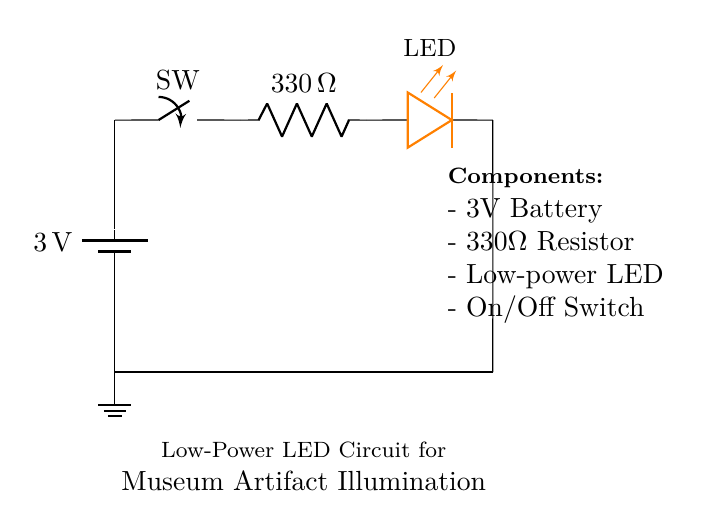What is the voltage of this circuit? The voltage of the circuit is 3 volts, indicated by the battery symbol labeled with this voltage in the diagram.
Answer: 3 volts What is the resistance value in this circuit? The resistance value is 330 ohms, as shown next to the resistor component in the diagram.
Answer: 330 ohms Which component provides illumination? The LED component provides illumination, indicated in the circuit by the label "LED" and its visual representation among the components.
Answer: LED What is the role of the switch in the circuit? The switch controls the flow of current; when turned on, it allows the circuit to complete and the LED to light up, while turning it off stops the current.
Answer: Control How does the resistor affect the LED? The resistor limits the current flowing to the LED to a safe level so it does not burn out, providing necessary protection in low-power applications.
Answer: Protection How does this circuit type classify under power consumption? This circuit is designed for low power consumption, which is ideal for battery-operated applications, specifically for illuminating artifacts in a museum display without excessive energy use.
Answer: Low power 